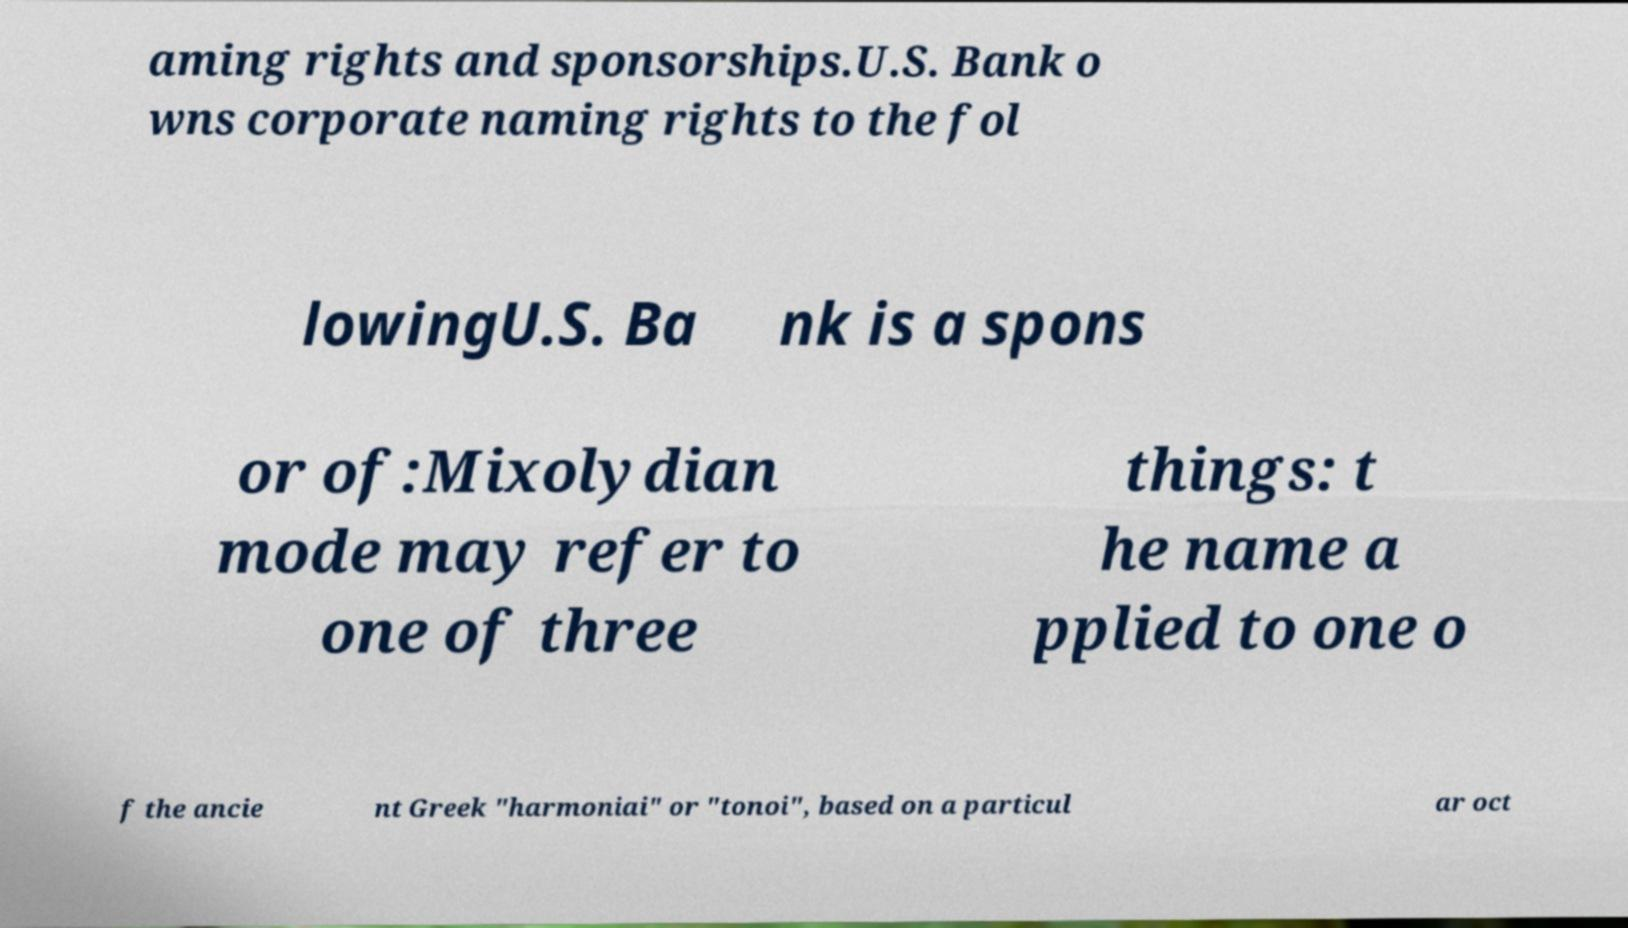Please identify and transcribe the text found in this image. aming rights and sponsorships.U.S. Bank o wns corporate naming rights to the fol lowingU.S. Ba nk is a spons or of:Mixolydian mode may refer to one of three things: t he name a pplied to one o f the ancie nt Greek "harmoniai" or "tonoi", based on a particul ar oct 